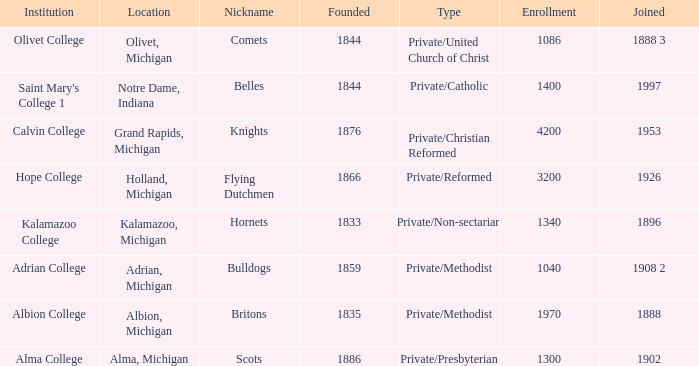In 1833, how many institutions were created? 1.0. 